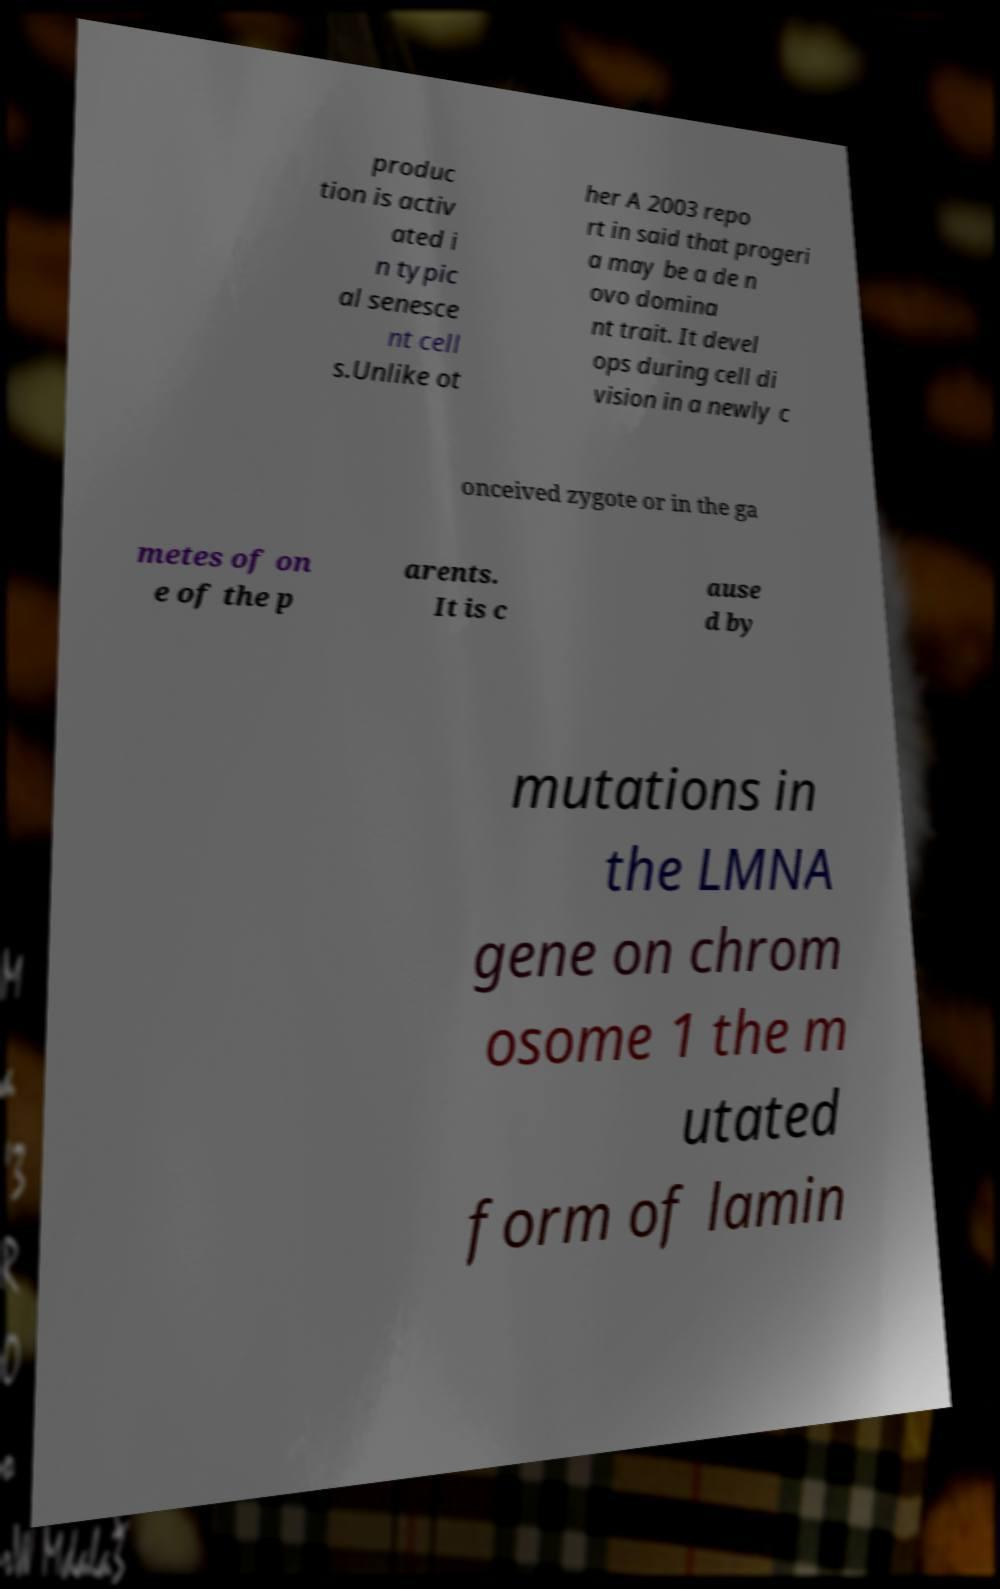For documentation purposes, I need the text within this image transcribed. Could you provide that? produc tion is activ ated i n typic al senesce nt cell s.Unlike ot her A 2003 repo rt in said that progeri a may be a de n ovo domina nt trait. It devel ops during cell di vision in a newly c onceived zygote or in the ga metes of on e of the p arents. It is c ause d by mutations in the LMNA gene on chrom osome 1 the m utated form of lamin 